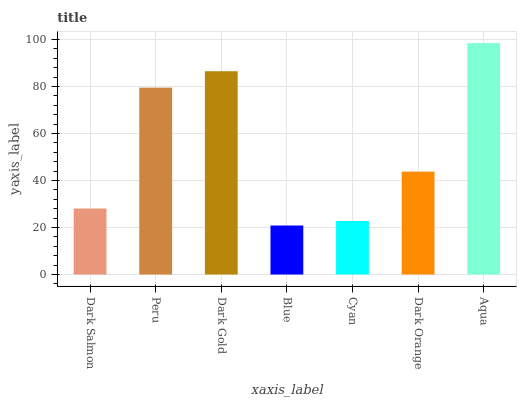Is Blue the minimum?
Answer yes or no. Yes. Is Aqua the maximum?
Answer yes or no. Yes. Is Peru the minimum?
Answer yes or no. No. Is Peru the maximum?
Answer yes or no. No. Is Peru greater than Dark Salmon?
Answer yes or no. Yes. Is Dark Salmon less than Peru?
Answer yes or no. Yes. Is Dark Salmon greater than Peru?
Answer yes or no. No. Is Peru less than Dark Salmon?
Answer yes or no. No. Is Dark Orange the high median?
Answer yes or no. Yes. Is Dark Orange the low median?
Answer yes or no. Yes. Is Dark Salmon the high median?
Answer yes or no. No. Is Dark Gold the low median?
Answer yes or no. No. 